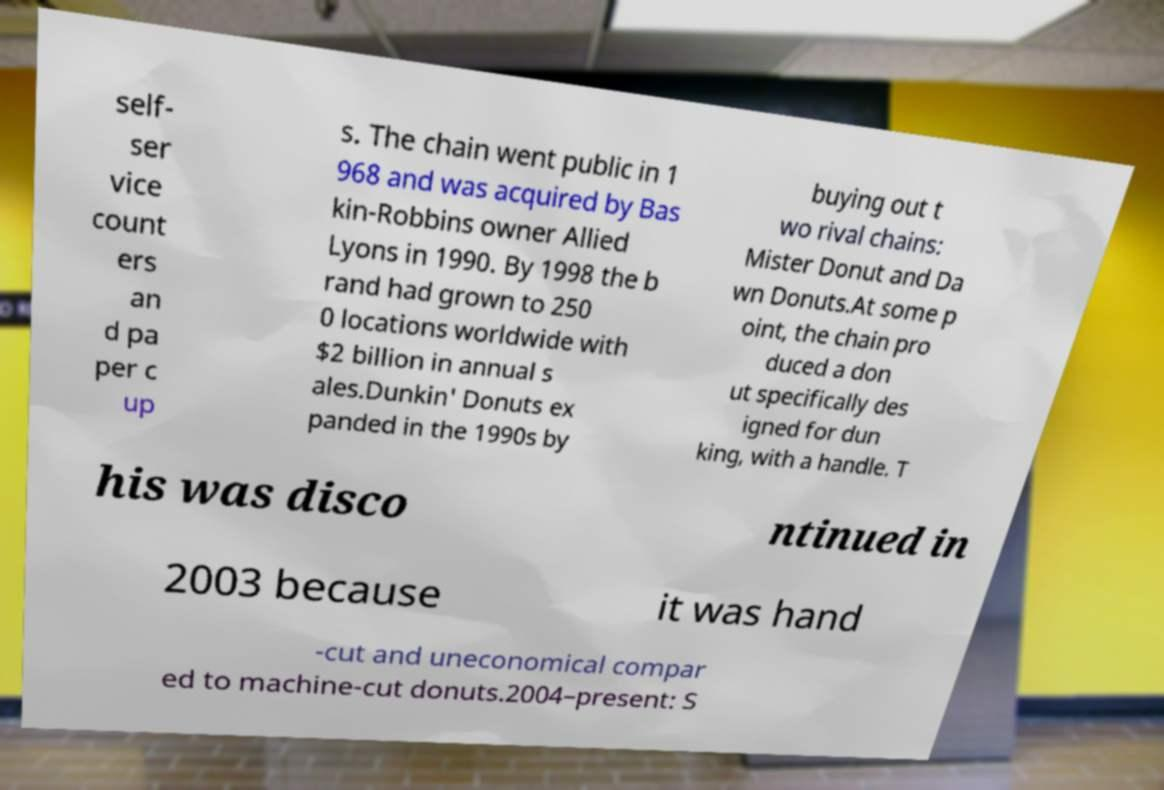Can you accurately transcribe the text from the provided image for me? self- ser vice count ers an d pa per c up s. The chain went public in 1 968 and was acquired by Bas kin-Robbins owner Allied Lyons in 1990. By 1998 the b rand had grown to 250 0 locations worldwide with $2 billion in annual s ales.Dunkin' Donuts ex panded in the 1990s by buying out t wo rival chains: Mister Donut and Da wn Donuts.At some p oint, the chain pro duced a don ut specifically des igned for dun king, with a handle. T his was disco ntinued in 2003 because it was hand -cut and uneconomical compar ed to machine-cut donuts.2004–present: S 